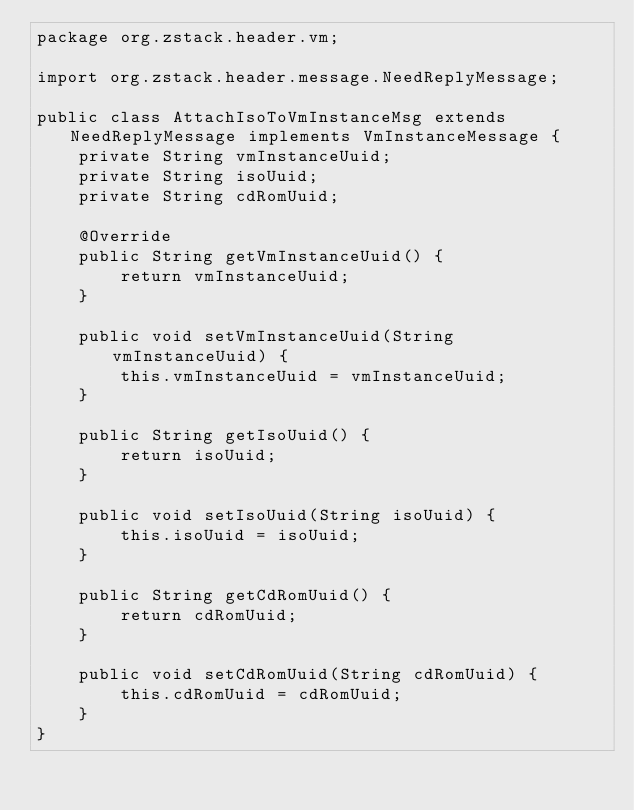<code> <loc_0><loc_0><loc_500><loc_500><_Java_>package org.zstack.header.vm;

import org.zstack.header.message.NeedReplyMessage;

public class AttachIsoToVmInstanceMsg extends NeedReplyMessage implements VmInstanceMessage {
    private String vmInstanceUuid;
    private String isoUuid;
    private String cdRomUuid;

    @Override
    public String getVmInstanceUuid() {
        return vmInstanceUuid;
    }

    public void setVmInstanceUuid(String vmInstanceUuid) {
        this.vmInstanceUuid = vmInstanceUuid;
    }

    public String getIsoUuid() {
        return isoUuid;
    }

    public void setIsoUuid(String isoUuid) {
        this.isoUuid = isoUuid;
    }

    public String getCdRomUuid() {
        return cdRomUuid;
    }

    public void setCdRomUuid(String cdRomUuid) {
        this.cdRomUuid = cdRomUuid;
    }
}
</code> 